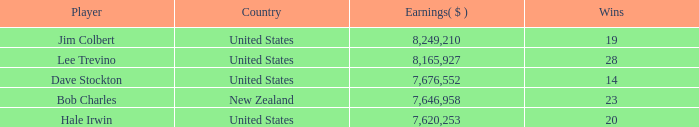How many average wins for players ranked below 2 with earnings greater than $7,676,552? None. 